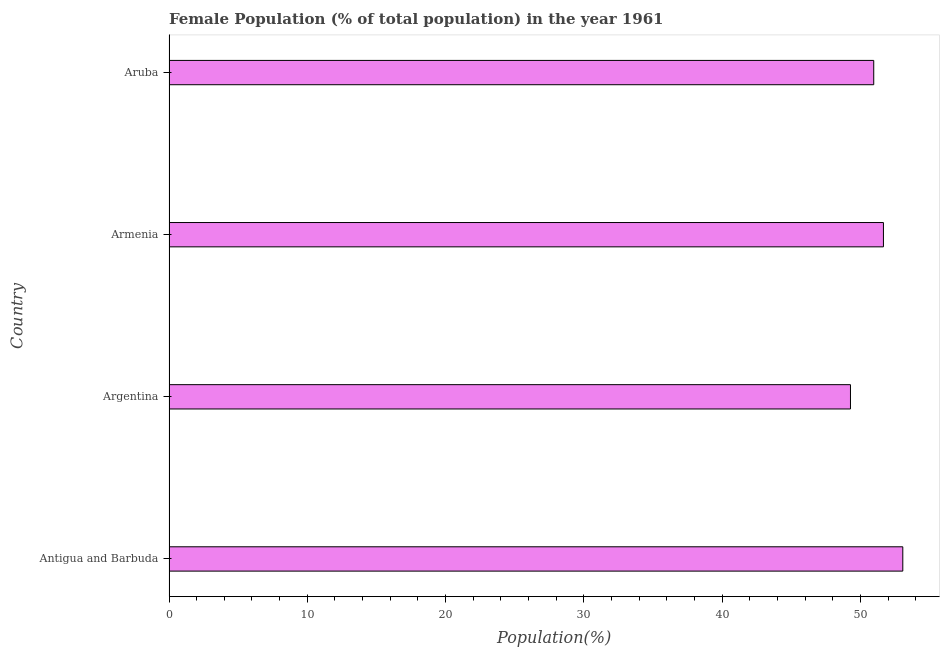Does the graph contain grids?
Provide a short and direct response. No. What is the title of the graph?
Keep it short and to the point. Female Population (% of total population) in the year 1961. What is the label or title of the X-axis?
Your answer should be very brief. Population(%). What is the female population in Aruba?
Provide a short and direct response. 50.96. Across all countries, what is the maximum female population?
Offer a terse response. 53.06. Across all countries, what is the minimum female population?
Offer a very short reply. 49.28. In which country was the female population maximum?
Make the answer very short. Antigua and Barbuda. What is the sum of the female population?
Your response must be concise. 204.97. What is the difference between the female population in Armenia and Aruba?
Keep it short and to the point. 0.7. What is the average female population per country?
Offer a very short reply. 51.24. What is the median female population?
Make the answer very short. 51.31. In how many countries, is the female population greater than 30 %?
Make the answer very short. 4. What is the ratio of the female population in Antigua and Barbuda to that in Aruba?
Offer a very short reply. 1.04. Is the female population in Argentina less than that in Armenia?
Give a very brief answer. Yes. Is the difference between the female population in Armenia and Aruba greater than the difference between any two countries?
Offer a very short reply. No. What is the difference between the highest and the second highest female population?
Ensure brevity in your answer.  1.4. What is the difference between the highest and the lowest female population?
Give a very brief answer. 3.78. How many countries are there in the graph?
Offer a very short reply. 4. Are the values on the major ticks of X-axis written in scientific E-notation?
Your response must be concise. No. What is the Population(%) in Antigua and Barbuda?
Keep it short and to the point. 53.06. What is the Population(%) of Argentina?
Your response must be concise. 49.28. What is the Population(%) in Armenia?
Keep it short and to the point. 51.66. What is the Population(%) in Aruba?
Offer a very short reply. 50.96. What is the difference between the Population(%) in Antigua and Barbuda and Argentina?
Provide a short and direct response. 3.78. What is the difference between the Population(%) in Antigua and Barbuda and Armenia?
Your answer should be compact. 1.4. What is the difference between the Population(%) in Antigua and Barbuda and Aruba?
Keep it short and to the point. 2.1. What is the difference between the Population(%) in Argentina and Armenia?
Your answer should be compact. -2.38. What is the difference between the Population(%) in Argentina and Aruba?
Keep it short and to the point. -1.68. What is the difference between the Population(%) in Armenia and Aruba?
Your answer should be compact. 0.7. What is the ratio of the Population(%) in Antigua and Barbuda to that in Argentina?
Give a very brief answer. 1.08. What is the ratio of the Population(%) in Antigua and Barbuda to that in Aruba?
Keep it short and to the point. 1.04. What is the ratio of the Population(%) in Argentina to that in Armenia?
Ensure brevity in your answer.  0.95. 